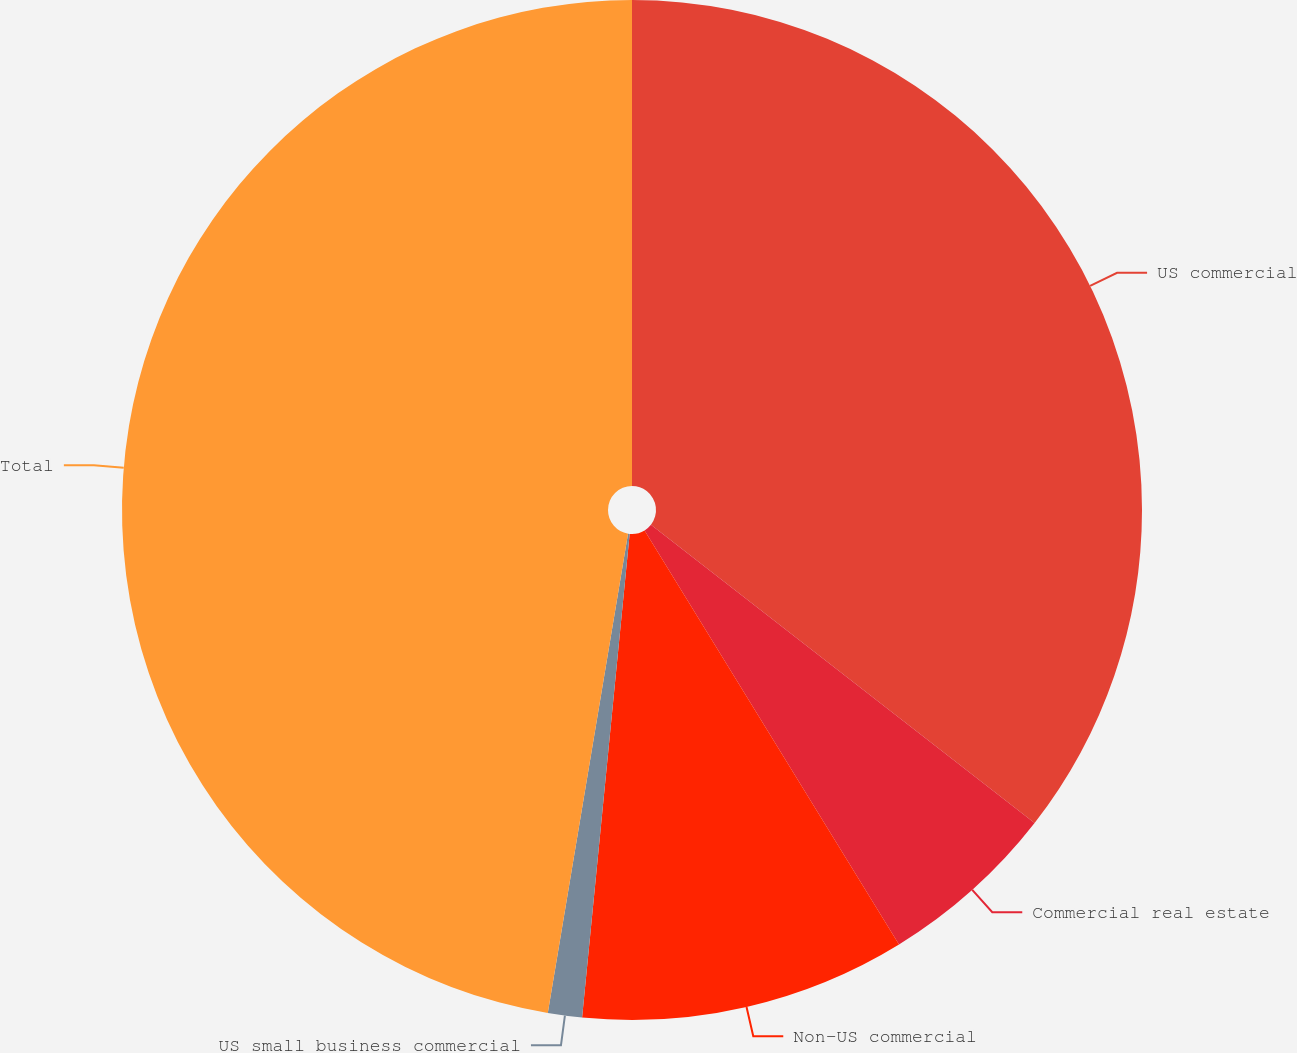<chart> <loc_0><loc_0><loc_500><loc_500><pie_chart><fcel>US commercial<fcel>Commercial real estate<fcel>Non-US commercial<fcel>US small business commercial<fcel>Total<nl><fcel>35.52%<fcel>5.71%<fcel>10.33%<fcel>1.08%<fcel>47.36%<nl></chart> 